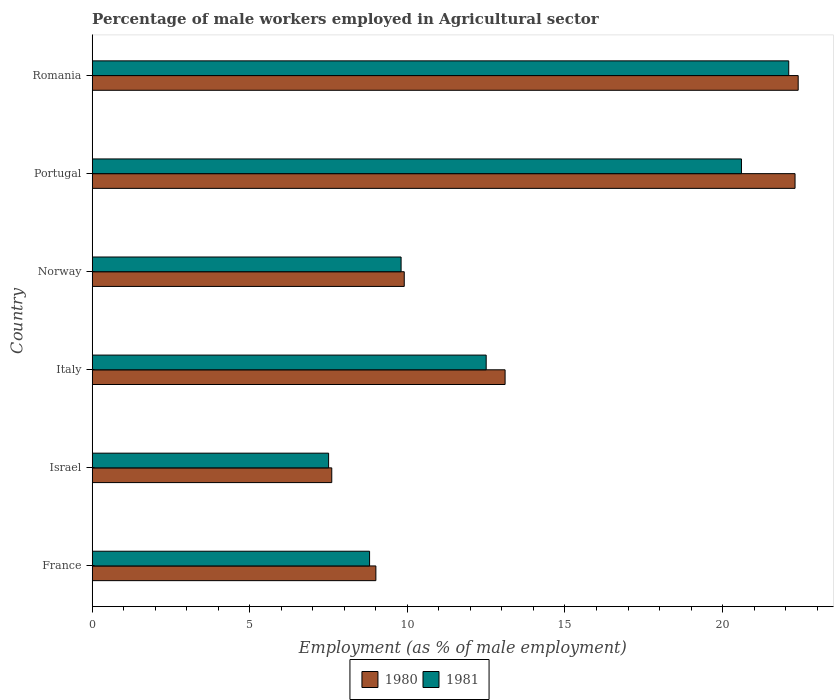Are the number of bars per tick equal to the number of legend labels?
Your response must be concise. Yes. Are the number of bars on each tick of the Y-axis equal?
Your answer should be very brief. Yes. How many bars are there on the 3rd tick from the top?
Your answer should be compact. 2. How many bars are there on the 5th tick from the bottom?
Your answer should be compact. 2. What is the label of the 4th group of bars from the top?
Keep it short and to the point. Italy. In how many cases, is the number of bars for a given country not equal to the number of legend labels?
Provide a succinct answer. 0. What is the percentage of male workers employed in Agricultural sector in 1980 in Italy?
Provide a succinct answer. 13.1. Across all countries, what is the maximum percentage of male workers employed in Agricultural sector in 1981?
Ensure brevity in your answer.  22.1. In which country was the percentage of male workers employed in Agricultural sector in 1980 maximum?
Your answer should be very brief. Romania. In which country was the percentage of male workers employed in Agricultural sector in 1980 minimum?
Your answer should be compact. Israel. What is the total percentage of male workers employed in Agricultural sector in 1981 in the graph?
Offer a terse response. 81.3. What is the difference between the percentage of male workers employed in Agricultural sector in 1981 in Israel and that in Romania?
Ensure brevity in your answer.  -14.6. What is the difference between the percentage of male workers employed in Agricultural sector in 1981 in Portugal and the percentage of male workers employed in Agricultural sector in 1980 in France?
Offer a very short reply. 11.6. What is the average percentage of male workers employed in Agricultural sector in 1981 per country?
Provide a succinct answer. 13.55. What is the difference between the percentage of male workers employed in Agricultural sector in 1981 and percentage of male workers employed in Agricultural sector in 1980 in Israel?
Ensure brevity in your answer.  -0.1. In how many countries, is the percentage of male workers employed in Agricultural sector in 1980 greater than 5 %?
Ensure brevity in your answer.  6. What is the ratio of the percentage of male workers employed in Agricultural sector in 1980 in Israel to that in Portugal?
Offer a terse response. 0.34. Is the percentage of male workers employed in Agricultural sector in 1981 in Norway less than that in Romania?
Give a very brief answer. Yes. Is the difference between the percentage of male workers employed in Agricultural sector in 1981 in Norway and Portugal greater than the difference between the percentage of male workers employed in Agricultural sector in 1980 in Norway and Portugal?
Your answer should be compact. Yes. What is the difference between the highest and the second highest percentage of male workers employed in Agricultural sector in 1981?
Ensure brevity in your answer.  1.5. What is the difference between the highest and the lowest percentage of male workers employed in Agricultural sector in 1980?
Provide a short and direct response. 14.8. Is the sum of the percentage of male workers employed in Agricultural sector in 1980 in France and Romania greater than the maximum percentage of male workers employed in Agricultural sector in 1981 across all countries?
Your answer should be very brief. Yes. Are all the bars in the graph horizontal?
Your answer should be compact. Yes. Are the values on the major ticks of X-axis written in scientific E-notation?
Your answer should be compact. No. Does the graph contain any zero values?
Keep it short and to the point. No. Does the graph contain grids?
Make the answer very short. No. What is the title of the graph?
Provide a short and direct response. Percentage of male workers employed in Agricultural sector. What is the label or title of the X-axis?
Offer a very short reply. Employment (as % of male employment). What is the Employment (as % of male employment) in 1981 in France?
Keep it short and to the point. 8.8. What is the Employment (as % of male employment) in 1980 in Israel?
Give a very brief answer. 7.6. What is the Employment (as % of male employment) of 1980 in Italy?
Give a very brief answer. 13.1. What is the Employment (as % of male employment) of 1981 in Italy?
Provide a succinct answer. 12.5. What is the Employment (as % of male employment) in 1980 in Norway?
Offer a terse response. 9.9. What is the Employment (as % of male employment) of 1981 in Norway?
Give a very brief answer. 9.8. What is the Employment (as % of male employment) in 1980 in Portugal?
Offer a terse response. 22.3. What is the Employment (as % of male employment) in 1981 in Portugal?
Provide a succinct answer. 20.6. What is the Employment (as % of male employment) in 1980 in Romania?
Offer a terse response. 22.4. What is the Employment (as % of male employment) in 1981 in Romania?
Provide a succinct answer. 22.1. Across all countries, what is the maximum Employment (as % of male employment) in 1980?
Your answer should be compact. 22.4. Across all countries, what is the maximum Employment (as % of male employment) in 1981?
Keep it short and to the point. 22.1. Across all countries, what is the minimum Employment (as % of male employment) of 1980?
Ensure brevity in your answer.  7.6. What is the total Employment (as % of male employment) of 1980 in the graph?
Your response must be concise. 84.3. What is the total Employment (as % of male employment) of 1981 in the graph?
Provide a succinct answer. 81.3. What is the difference between the Employment (as % of male employment) in 1980 in France and that in Israel?
Ensure brevity in your answer.  1.4. What is the difference between the Employment (as % of male employment) of 1981 in France and that in Israel?
Offer a very short reply. 1.3. What is the difference between the Employment (as % of male employment) in 1980 in France and that in Italy?
Offer a terse response. -4.1. What is the difference between the Employment (as % of male employment) of 1981 in France and that in Norway?
Your answer should be compact. -1. What is the difference between the Employment (as % of male employment) in 1980 in France and that in Portugal?
Give a very brief answer. -13.3. What is the difference between the Employment (as % of male employment) in 1981 in France and that in Portugal?
Provide a short and direct response. -11.8. What is the difference between the Employment (as % of male employment) in 1981 in Israel and that in Norway?
Offer a terse response. -2.3. What is the difference between the Employment (as % of male employment) of 1980 in Israel and that in Portugal?
Your answer should be very brief. -14.7. What is the difference between the Employment (as % of male employment) of 1981 in Israel and that in Portugal?
Provide a short and direct response. -13.1. What is the difference between the Employment (as % of male employment) in 1980 in Israel and that in Romania?
Make the answer very short. -14.8. What is the difference between the Employment (as % of male employment) of 1981 in Israel and that in Romania?
Your answer should be compact. -14.6. What is the difference between the Employment (as % of male employment) of 1980 in Italy and that in Norway?
Ensure brevity in your answer.  3.2. What is the difference between the Employment (as % of male employment) in 1981 in Italy and that in Norway?
Make the answer very short. 2.7. What is the difference between the Employment (as % of male employment) in 1980 in Italy and that in Portugal?
Ensure brevity in your answer.  -9.2. What is the difference between the Employment (as % of male employment) in 1981 in Italy and that in Portugal?
Provide a short and direct response. -8.1. What is the difference between the Employment (as % of male employment) of 1981 in Italy and that in Romania?
Make the answer very short. -9.6. What is the difference between the Employment (as % of male employment) in 1980 in Norway and that in Portugal?
Provide a succinct answer. -12.4. What is the difference between the Employment (as % of male employment) of 1981 in Norway and that in Portugal?
Ensure brevity in your answer.  -10.8. What is the difference between the Employment (as % of male employment) in 1980 in Norway and that in Romania?
Your answer should be very brief. -12.5. What is the difference between the Employment (as % of male employment) in 1981 in Norway and that in Romania?
Make the answer very short. -12.3. What is the difference between the Employment (as % of male employment) in 1980 in France and the Employment (as % of male employment) in 1981 in Romania?
Give a very brief answer. -13.1. What is the difference between the Employment (as % of male employment) in 1980 in Israel and the Employment (as % of male employment) in 1981 in Norway?
Provide a short and direct response. -2.2. What is the difference between the Employment (as % of male employment) of 1980 in Israel and the Employment (as % of male employment) of 1981 in Portugal?
Give a very brief answer. -13. What is the difference between the Employment (as % of male employment) of 1980 in Italy and the Employment (as % of male employment) of 1981 in Portugal?
Provide a short and direct response. -7.5. What is the difference between the Employment (as % of male employment) of 1980 in Portugal and the Employment (as % of male employment) of 1981 in Romania?
Provide a short and direct response. 0.2. What is the average Employment (as % of male employment) in 1980 per country?
Provide a succinct answer. 14.05. What is the average Employment (as % of male employment) of 1981 per country?
Offer a very short reply. 13.55. What is the difference between the Employment (as % of male employment) in 1980 and Employment (as % of male employment) in 1981 in Israel?
Your answer should be compact. 0.1. What is the difference between the Employment (as % of male employment) of 1980 and Employment (as % of male employment) of 1981 in Italy?
Your answer should be very brief. 0.6. What is the ratio of the Employment (as % of male employment) in 1980 in France to that in Israel?
Provide a succinct answer. 1.18. What is the ratio of the Employment (as % of male employment) in 1981 in France to that in Israel?
Give a very brief answer. 1.17. What is the ratio of the Employment (as % of male employment) of 1980 in France to that in Italy?
Make the answer very short. 0.69. What is the ratio of the Employment (as % of male employment) of 1981 in France to that in Italy?
Ensure brevity in your answer.  0.7. What is the ratio of the Employment (as % of male employment) of 1980 in France to that in Norway?
Your answer should be very brief. 0.91. What is the ratio of the Employment (as % of male employment) in 1981 in France to that in Norway?
Offer a terse response. 0.9. What is the ratio of the Employment (as % of male employment) of 1980 in France to that in Portugal?
Your response must be concise. 0.4. What is the ratio of the Employment (as % of male employment) of 1981 in France to that in Portugal?
Offer a terse response. 0.43. What is the ratio of the Employment (as % of male employment) of 1980 in France to that in Romania?
Make the answer very short. 0.4. What is the ratio of the Employment (as % of male employment) in 1981 in France to that in Romania?
Offer a terse response. 0.4. What is the ratio of the Employment (as % of male employment) of 1980 in Israel to that in Italy?
Give a very brief answer. 0.58. What is the ratio of the Employment (as % of male employment) in 1980 in Israel to that in Norway?
Offer a very short reply. 0.77. What is the ratio of the Employment (as % of male employment) in 1981 in Israel to that in Norway?
Offer a terse response. 0.77. What is the ratio of the Employment (as % of male employment) in 1980 in Israel to that in Portugal?
Provide a succinct answer. 0.34. What is the ratio of the Employment (as % of male employment) in 1981 in Israel to that in Portugal?
Provide a short and direct response. 0.36. What is the ratio of the Employment (as % of male employment) of 1980 in Israel to that in Romania?
Offer a very short reply. 0.34. What is the ratio of the Employment (as % of male employment) of 1981 in Israel to that in Romania?
Provide a succinct answer. 0.34. What is the ratio of the Employment (as % of male employment) of 1980 in Italy to that in Norway?
Provide a succinct answer. 1.32. What is the ratio of the Employment (as % of male employment) of 1981 in Italy to that in Norway?
Make the answer very short. 1.28. What is the ratio of the Employment (as % of male employment) of 1980 in Italy to that in Portugal?
Keep it short and to the point. 0.59. What is the ratio of the Employment (as % of male employment) in 1981 in Italy to that in Portugal?
Your answer should be very brief. 0.61. What is the ratio of the Employment (as % of male employment) in 1980 in Italy to that in Romania?
Ensure brevity in your answer.  0.58. What is the ratio of the Employment (as % of male employment) of 1981 in Italy to that in Romania?
Provide a succinct answer. 0.57. What is the ratio of the Employment (as % of male employment) of 1980 in Norway to that in Portugal?
Ensure brevity in your answer.  0.44. What is the ratio of the Employment (as % of male employment) of 1981 in Norway to that in Portugal?
Provide a short and direct response. 0.48. What is the ratio of the Employment (as % of male employment) in 1980 in Norway to that in Romania?
Ensure brevity in your answer.  0.44. What is the ratio of the Employment (as % of male employment) in 1981 in Norway to that in Romania?
Keep it short and to the point. 0.44. What is the ratio of the Employment (as % of male employment) in 1980 in Portugal to that in Romania?
Your response must be concise. 1. What is the ratio of the Employment (as % of male employment) of 1981 in Portugal to that in Romania?
Provide a short and direct response. 0.93. What is the difference between the highest and the second highest Employment (as % of male employment) of 1980?
Your response must be concise. 0.1. What is the difference between the highest and the lowest Employment (as % of male employment) of 1980?
Make the answer very short. 14.8. What is the difference between the highest and the lowest Employment (as % of male employment) in 1981?
Provide a succinct answer. 14.6. 